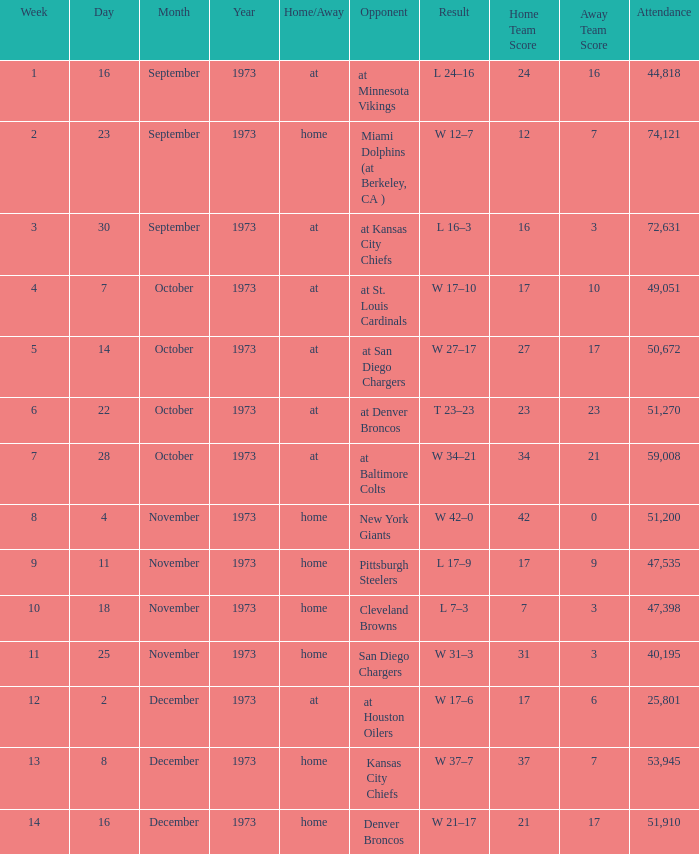What is the highest number in attendance against the game at Kansas City Chiefs? 72631.0. 